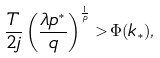Convert formula to latex. <formula><loc_0><loc_0><loc_500><loc_500>\frac { T } { 2 j } \left ( \frac { \lambda p ^ { * } } { q } \right ) ^ { \frac { 1 } { p } } > \Phi ( k _ { * } ) ,</formula> 